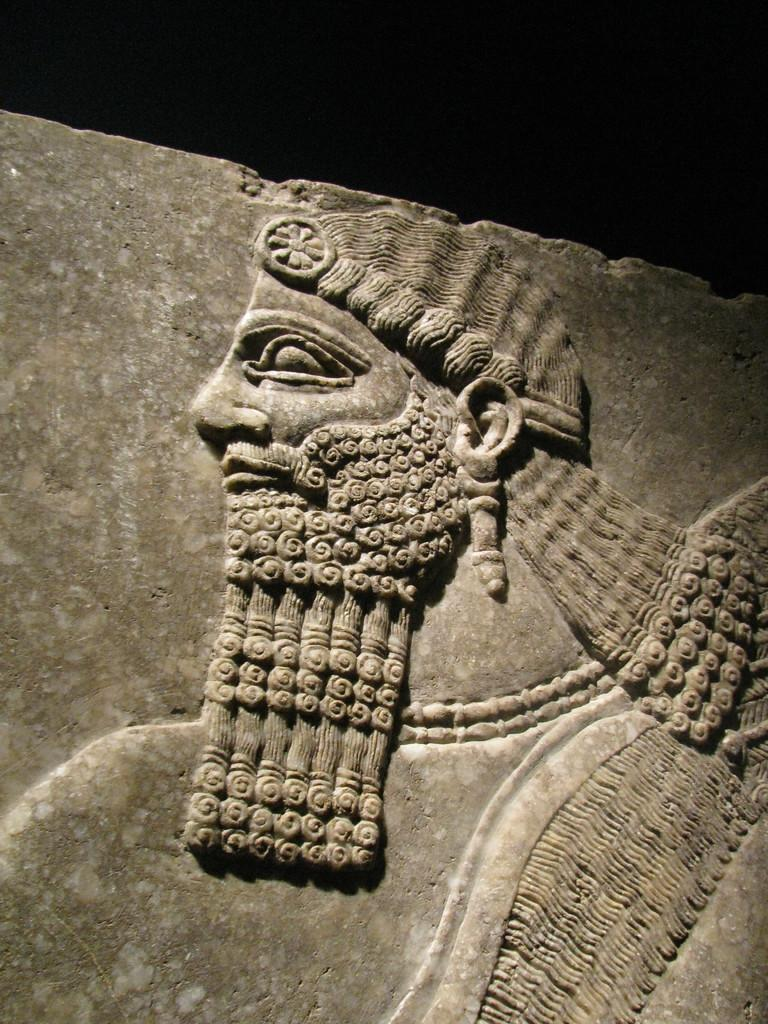What is depicted on the stone in the image? There is a carving of a person on a stone in the image. Can you describe the carving in more detail? Unfortunately, the provided facts do not offer more detail about the carving. What material is the carving made of? The carving is made of stone, as mentioned in the fact. How many children are playing in the war depicted in the image? There is no depiction of children or war in the image; it features a carving of a person on a stone. 